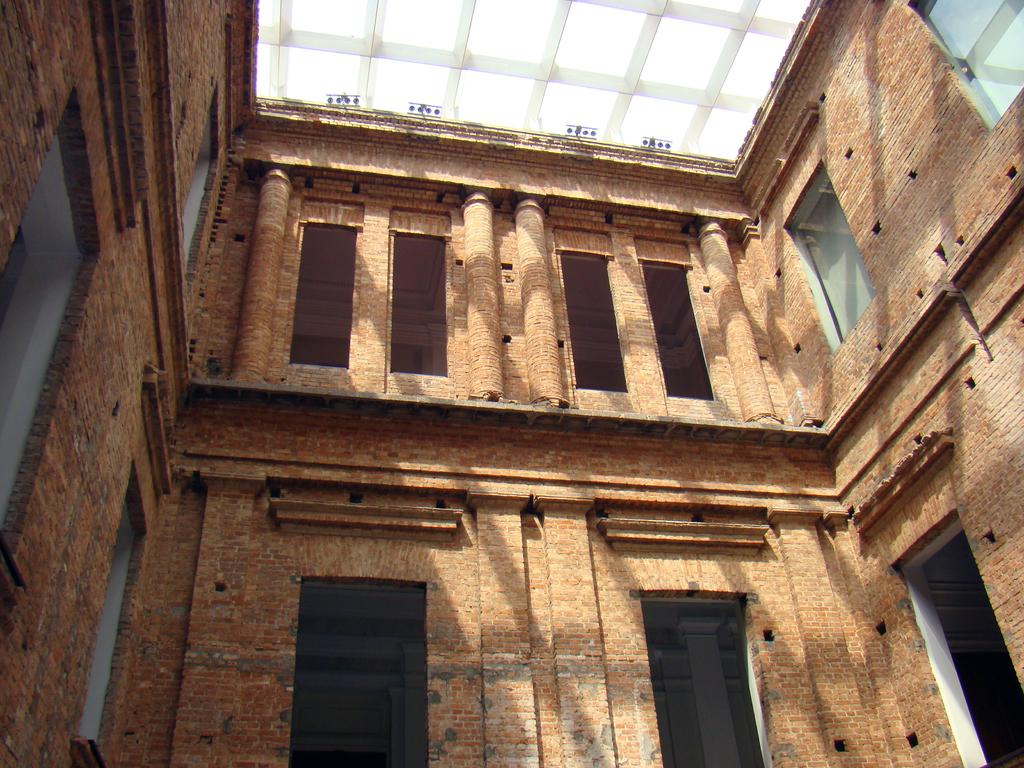What type of structure is visible in the image? There is a building in the image. What feature can be seen on the building? There are windows in the image. How many houses are visible in the image? There are no houses visible in the image; it features a building with windows. What type of lift system is present in the image? There is no lift system present in the image. 